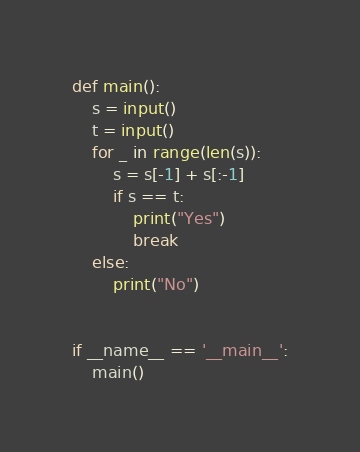Convert code to text. <code><loc_0><loc_0><loc_500><loc_500><_Python_>def main():
    s = input()
    t = input()
    for _ in range(len(s)):
        s = s[-1] + s[:-1]
        if s == t:
            print("Yes")
            break
    else:
        print("No")


if __name__ == '__main__':
    main()

</code> 